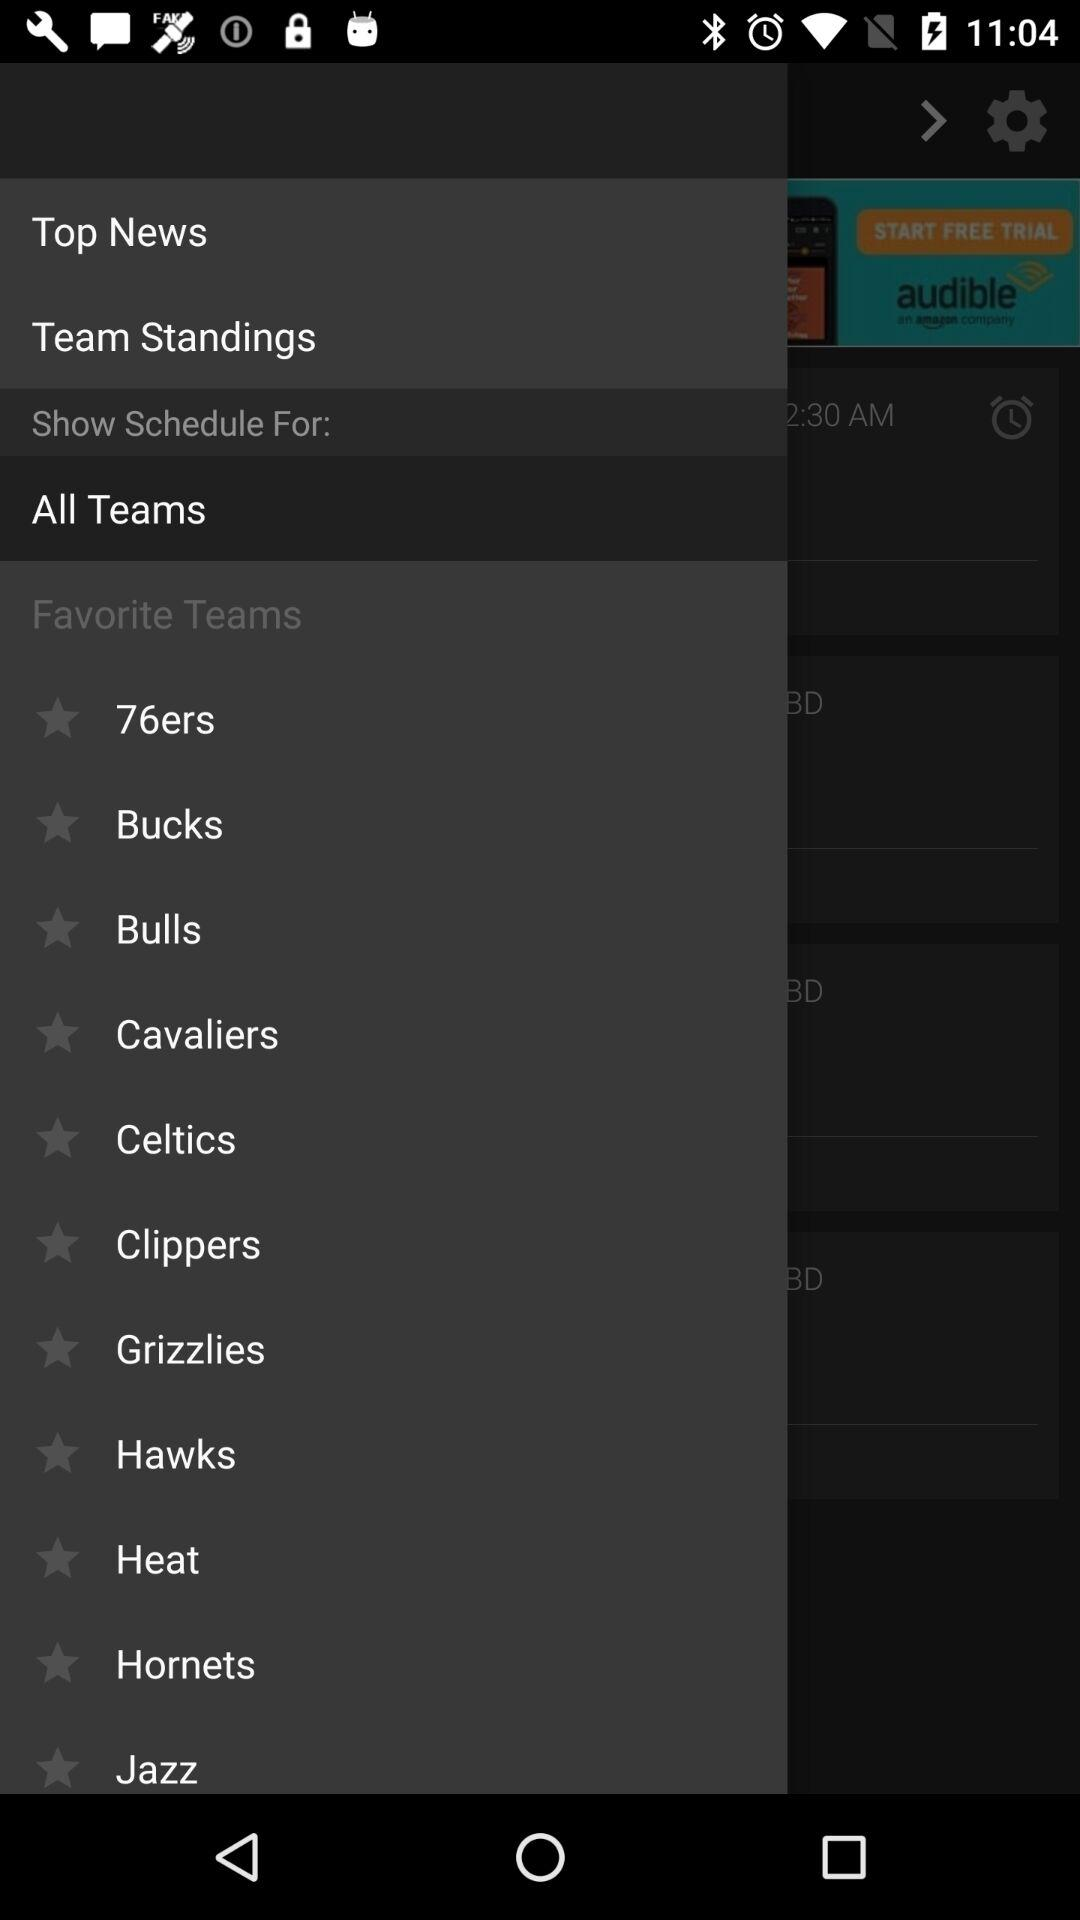What are the favorite teams? The favorite teams are "76ers", "Bucks", "Bulls", "Cavaliers", "Celtics", "Clippers", "Grizzlies", "Hawks", "Heat", "Hornets" and "Jazz". 